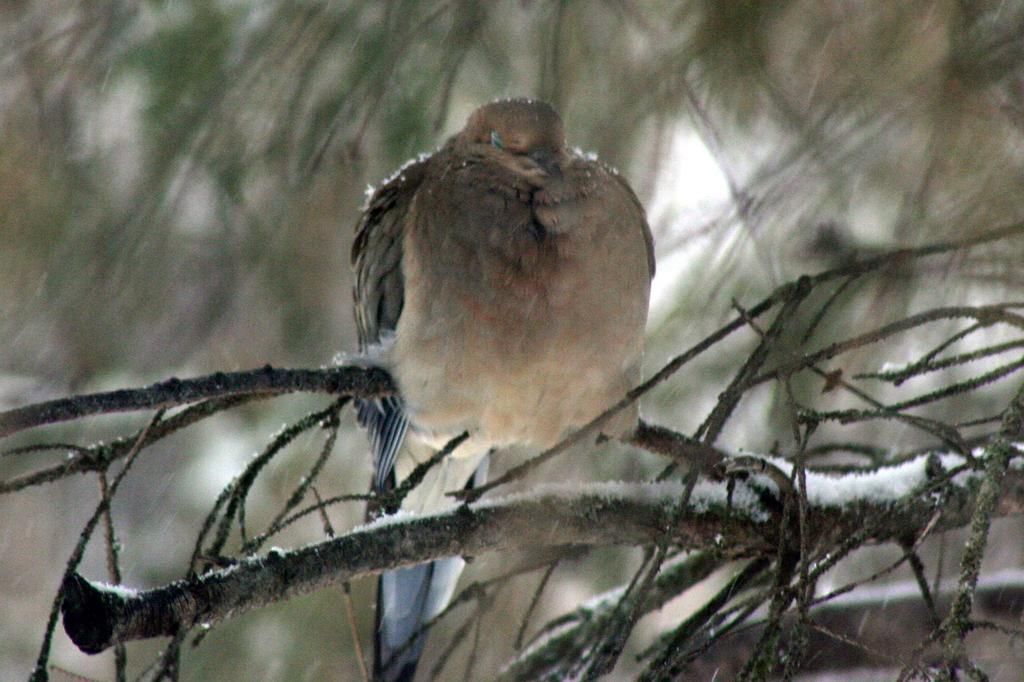What can be observed about the background of the image? The background of the image is blurry. What type of animal is present in the image? There is a bird in the image. What else can be seen in the image besides the bird? There are branches in the image. What type of wave is depicted in the image? There is no wave present in the image; it features a bird and branches. What invention is being used by the bird in the image? The bird is not using any invention in the image; it is simply perched on the branches. 